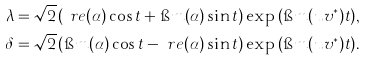<formula> <loc_0><loc_0><loc_500><loc_500>\lambda & = \sqrt { 2 } \left ( \ r e { ( \alpha ) } \cos { t } + \i m { ( \alpha ) } \sin { t } \right ) \exp { \left ( \i m ( u v ^ { * } ) t \right ) } , \\ \delta & = \sqrt { 2 } \left ( \i m { ( \alpha ) } \cos { t } - \ r e { ( \alpha ) } \sin { t } \right ) \exp { \left ( \i m ( u v ^ { * } ) t \right ) } .</formula> 